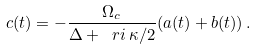Convert formula to latex. <formula><loc_0><loc_0><loc_500><loc_500>c ( t ) = - \frac { \Omega _ { c } } { \Delta + \ r i \, \kappa / 2 } ( a ( t ) + b ( t ) ) \, .</formula> 